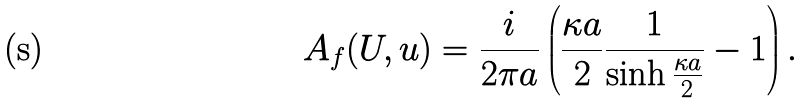Convert formula to latex. <formula><loc_0><loc_0><loc_500><loc_500>A _ { f } ( U , u ) = \frac { i } { 2 \pi a } \left ( \frac { \kappa a } { 2 } \frac { 1 } { \sinh \frac { \kappa a } { 2 } } - 1 \right ) .</formula> 